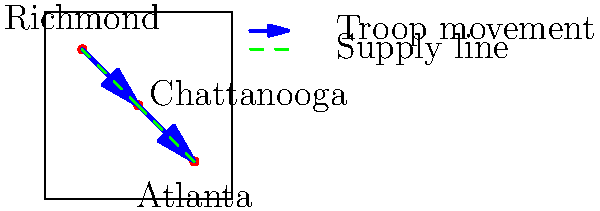Based on the visualization of troop movements and supply lines during a major Civil War campaign, what was likely the primary objective of the Union forces, and which strategically important city served as an intermediate point in their advance? To answer this question, let's analyze the map step-by-step:

1. We can see three cities marked on the map: Richmond, Chattanooga, and Atlanta.

2. The blue arrows represent troop movements, while the dashed green lines represent supply lines.

3. The troop movement starts from Richmond in the north, passes through Chattanooga in the center, and ends at Atlanta in the south.

4. This pattern suggests a southward advance by Union forces, as Richmond was the capital of the Confederacy and would likely be the starting point for Union troops.

5. Chattanooga is positioned between Richmond and Atlanta, serving as an intermediate point in the campaign.

6. Atlanta, being the southernmost city on the map and the endpoint of the troop movement, is likely the primary objective of this campaign.

7. Chattanooga's strategic importance is evident from its position as a midpoint, where both troop movements and supply lines intersect.

Given this analysis, we can conclude that the primary objective of the Union forces was likely Atlanta, with Chattanooga serving as a crucial intermediate point in their advance.
Answer: Atlanta; Chattanooga 